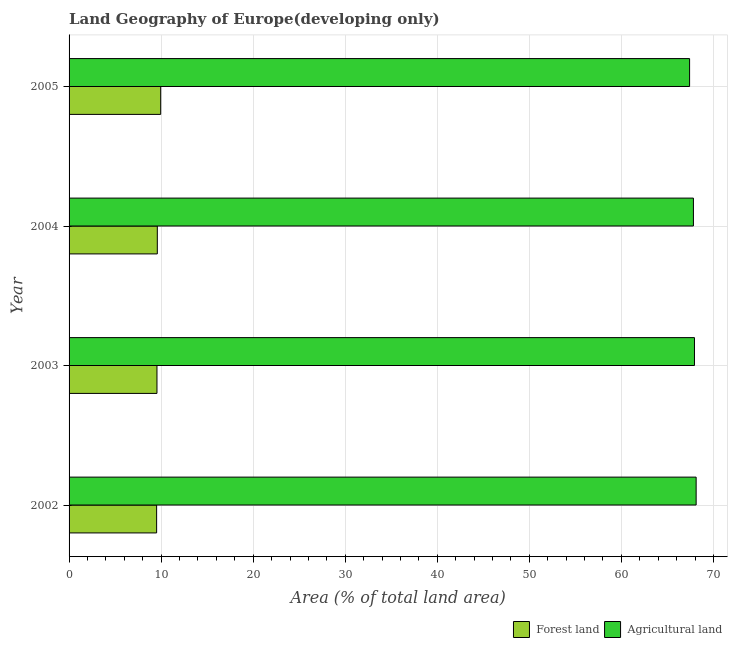How many different coloured bars are there?
Keep it short and to the point. 2. Are the number of bars per tick equal to the number of legend labels?
Give a very brief answer. Yes. Are the number of bars on each tick of the Y-axis equal?
Make the answer very short. Yes. How many bars are there on the 3rd tick from the top?
Offer a terse response. 2. What is the percentage of land area under forests in 2004?
Your response must be concise. 9.59. Across all years, what is the maximum percentage of land area under forests?
Offer a very short reply. 9.95. Across all years, what is the minimum percentage of land area under agriculture?
Provide a succinct answer. 67.41. In which year was the percentage of land area under agriculture minimum?
Make the answer very short. 2005. What is the total percentage of land area under forests in the graph?
Give a very brief answer. 38.6. What is the difference between the percentage of land area under forests in 2003 and that in 2004?
Give a very brief answer. -0.04. What is the difference between the percentage of land area under agriculture in 2005 and the percentage of land area under forests in 2002?
Your answer should be compact. 57.9. What is the average percentage of land area under forests per year?
Give a very brief answer. 9.65. In the year 2003, what is the difference between the percentage of land area under agriculture and percentage of land area under forests?
Ensure brevity in your answer.  58.39. What is the ratio of the percentage of land area under forests in 2002 to that in 2004?
Provide a succinct answer. 0.99. What is the difference between the highest and the second highest percentage of land area under agriculture?
Ensure brevity in your answer.  0.18. What is the difference between the highest and the lowest percentage of land area under forests?
Give a very brief answer. 0.44. Is the sum of the percentage of land area under forests in 2004 and 2005 greater than the maximum percentage of land area under agriculture across all years?
Your response must be concise. No. What does the 1st bar from the top in 2004 represents?
Ensure brevity in your answer.  Agricultural land. What does the 2nd bar from the bottom in 2004 represents?
Your answer should be very brief. Agricultural land. How many bars are there?
Offer a very short reply. 8. What is the difference between two consecutive major ticks on the X-axis?
Your answer should be compact. 10. Are the values on the major ticks of X-axis written in scientific E-notation?
Your answer should be very brief. No. Where does the legend appear in the graph?
Provide a succinct answer. Bottom right. What is the title of the graph?
Provide a short and direct response. Land Geography of Europe(developing only). What is the label or title of the X-axis?
Make the answer very short. Area (% of total land area). What is the label or title of the Y-axis?
Your response must be concise. Year. What is the Area (% of total land area) of Forest land in 2002?
Make the answer very short. 9.51. What is the Area (% of total land area) in Agricultural land in 2002?
Offer a terse response. 68.12. What is the Area (% of total land area) in Forest land in 2003?
Provide a succinct answer. 9.55. What is the Area (% of total land area) of Agricultural land in 2003?
Offer a terse response. 67.94. What is the Area (% of total land area) of Forest land in 2004?
Make the answer very short. 9.59. What is the Area (% of total land area) of Agricultural land in 2004?
Your answer should be very brief. 67.82. What is the Area (% of total land area) in Forest land in 2005?
Keep it short and to the point. 9.95. What is the Area (% of total land area) in Agricultural land in 2005?
Keep it short and to the point. 67.41. Across all years, what is the maximum Area (% of total land area) of Forest land?
Make the answer very short. 9.95. Across all years, what is the maximum Area (% of total land area) in Agricultural land?
Keep it short and to the point. 68.12. Across all years, what is the minimum Area (% of total land area) in Forest land?
Keep it short and to the point. 9.51. Across all years, what is the minimum Area (% of total land area) in Agricultural land?
Ensure brevity in your answer.  67.41. What is the total Area (% of total land area) in Forest land in the graph?
Offer a terse response. 38.6. What is the total Area (% of total land area) of Agricultural land in the graph?
Provide a short and direct response. 271.29. What is the difference between the Area (% of total land area) in Forest land in 2002 and that in 2003?
Your response must be concise. -0.04. What is the difference between the Area (% of total land area) of Agricultural land in 2002 and that in 2003?
Make the answer very short. 0.18. What is the difference between the Area (% of total land area) of Forest land in 2002 and that in 2004?
Give a very brief answer. -0.08. What is the difference between the Area (% of total land area) of Agricultural land in 2002 and that in 2004?
Your response must be concise. 0.3. What is the difference between the Area (% of total land area) in Forest land in 2002 and that in 2005?
Offer a very short reply. -0.44. What is the difference between the Area (% of total land area) of Agricultural land in 2002 and that in 2005?
Ensure brevity in your answer.  0.71. What is the difference between the Area (% of total land area) of Forest land in 2003 and that in 2004?
Your answer should be compact. -0.04. What is the difference between the Area (% of total land area) in Agricultural land in 2003 and that in 2004?
Provide a succinct answer. 0.11. What is the difference between the Area (% of total land area) in Forest land in 2003 and that in 2005?
Keep it short and to the point. -0.4. What is the difference between the Area (% of total land area) of Agricultural land in 2003 and that in 2005?
Your response must be concise. 0.53. What is the difference between the Area (% of total land area) of Forest land in 2004 and that in 2005?
Make the answer very short. -0.37. What is the difference between the Area (% of total land area) of Agricultural land in 2004 and that in 2005?
Ensure brevity in your answer.  0.42. What is the difference between the Area (% of total land area) of Forest land in 2002 and the Area (% of total land area) of Agricultural land in 2003?
Your response must be concise. -58.43. What is the difference between the Area (% of total land area) in Forest land in 2002 and the Area (% of total land area) in Agricultural land in 2004?
Your response must be concise. -58.31. What is the difference between the Area (% of total land area) in Forest land in 2002 and the Area (% of total land area) in Agricultural land in 2005?
Make the answer very short. -57.9. What is the difference between the Area (% of total land area) of Forest land in 2003 and the Area (% of total land area) of Agricultural land in 2004?
Your answer should be very brief. -58.28. What is the difference between the Area (% of total land area) in Forest land in 2003 and the Area (% of total land area) in Agricultural land in 2005?
Ensure brevity in your answer.  -57.86. What is the difference between the Area (% of total land area) in Forest land in 2004 and the Area (% of total land area) in Agricultural land in 2005?
Your answer should be compact. -57.82. What is the average Area (% of total land area) of Forest land per year?
Ensure brevity in your answer.  9.65. What is the average Area (% of total land area) of Agricultural land per year?
Ensure brevity in your answer.  67.82. In the year 2002, what is the difference between the Area (% of total land area) of Forest land and Area (% of total land area) of Agricultural land?
Your answer should be very brief. -58.61. In the year 2003, what is the difference between the Area (% of total land area) in Forest land and Area (% of total land area) in Agricultural land?
Offer a terse response. -58.39. In the year 2004, what is the difference between the Area (% of total land area) in Forest land and Area (% of total land area) in Agricultural land?
Ensure brevity in your answer.  -58.24. In the year 2005, what is the difference between the Area (% of total land area) in Forest land and Area (% of total land area) in Agricultural land?
Your answer should be compact. -57.46. What is the ratio of the Area (% of total land area) of Agricultural land in 2002 to that in 2003?
Ensure brevity in your answer.  1. What is the ratio of the Area (% of total land area) of Forest land in 2002 to that in 2005?
Provide a succinct answer. 0.96. What is the ratio of the Area (% of total land area) in Agricultural land in 2002 to that in 2005?
Keep it short and to the point. 1.01. What is the ratio of the Area (% of total land area) in Forest land in 2003 to that in 2004?
Give a very brief answer. 1. What is the ratio of the Area (% of total land area) of Forest land in 2003 to that in 2005?
Ensure brevity in your answer.  0.96. What is the ratio of the Area (% of total land area) of Agricultural land in 2003 to that in 2005?
Offer a terse response. 1.01. What is the ratio of the Area (% of total land area) in Forest land in 2004 to that in 2005?
Make the answer very short. 0.96. What is the ratio of the Area (% of total land area) in Agricultural land in 2004 to that in 2005?
Offer a very short reply. 1.01. What is the difference between the highest and the second highest Area (% of total land area) of Forest land?
Keep it short and to the point. 0.37. What is the difference between the highest and the second highest Area (% of total land area) in Agricultural land?
Provide a succinct answer. 0.18. What is the difference between the highest and the lowest Area (% of total land area) in Forest land?
Give a very brief answer. 0.44. What is the difference between the highest and the lowest Area (% of total land area) of Agricultural land?
Offer a very short reply. 0.71. 